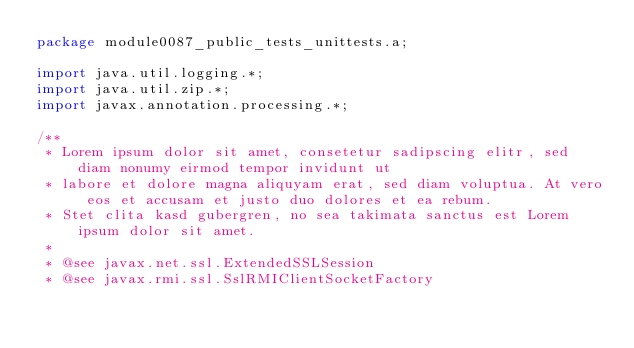<code> <loc_0><loc_0><loc_500><loc_500><_Java_>package module0087_public_tests_unittests.a;

import java.util.logging.*;
import java.util.zip.*;
import javax.annotation.processing.*;

/**
 * Lorem ipsum dolor sit amet, consetetur sadipscing elitr, sed diam nonumy eirmod tempor invidunt ut 
 * labore et dolore magna aliquyam erat, sed diam voluptua. At vero eos et accusam et justo duo dolores et ea rebum. 
 * Stet clita kasd gubergren, no sea takimata sanctus est Lorem ipsum dolor sit amet. 
 *
 * @see javax.net.ssl.ExtendedSSLSession
 * @see javax.rmi.ssl.SslRMIClientSocketFactory</code> 